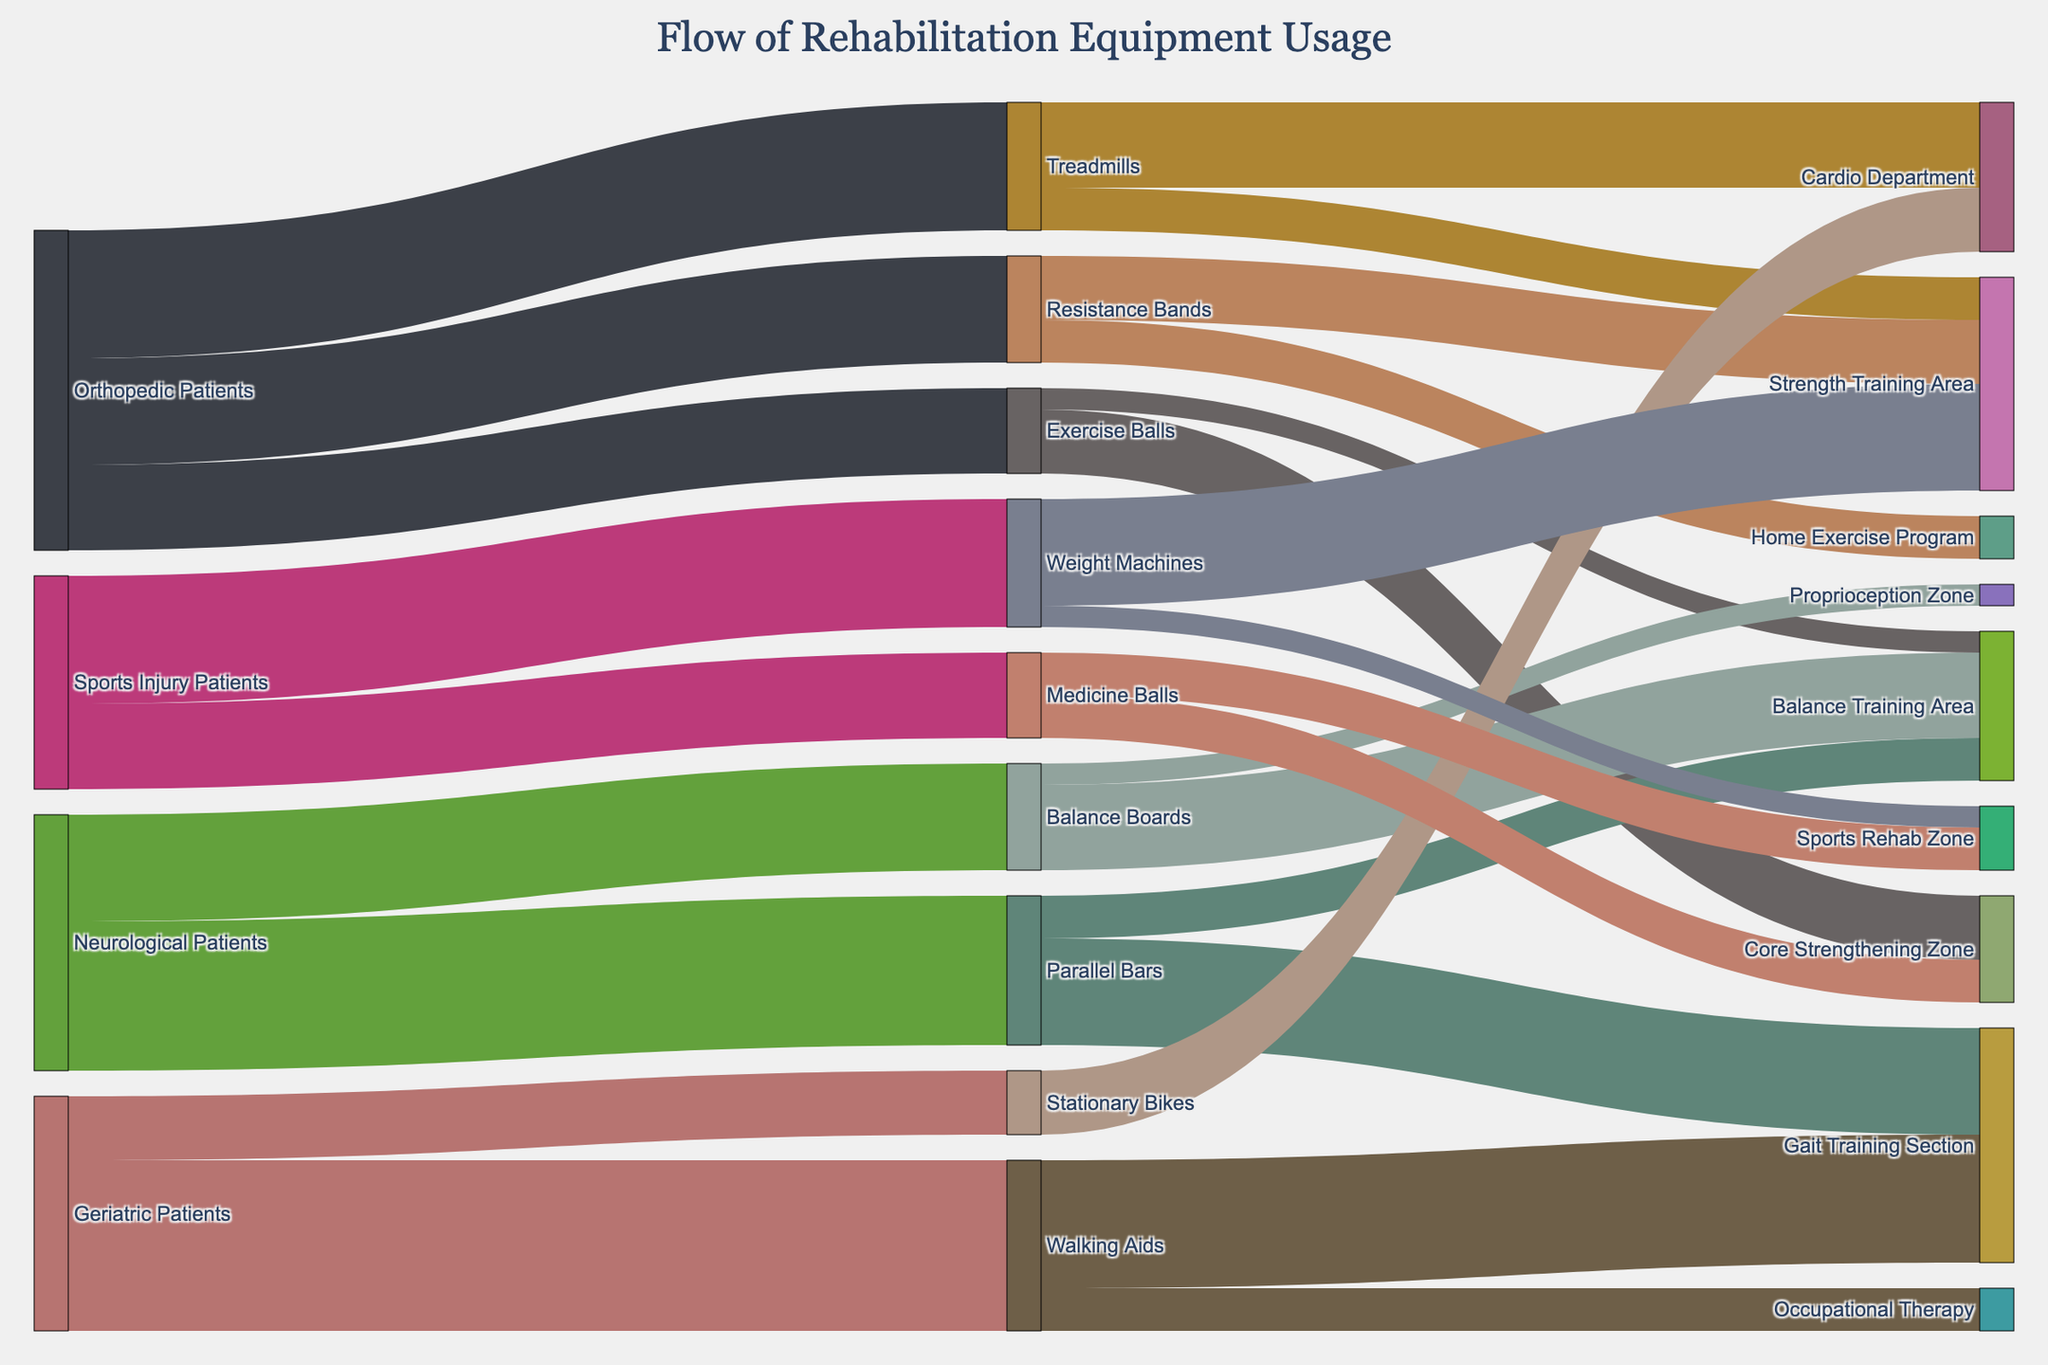What therapy department receives the most usage of Treadmills? Treadmills split usage between the Cardio Department and Strength Training Area. According to the figure, the Cardio Department receives 20 units, and the Strength Training Area receives 10 units. Therefore, the Cardio Department receives the most usage of Treadmills.
Answer: Cardio Department How many patient groups utilize the Resistance Bands? To determine this, identify all the distinct patient groups (source nodes) that flow into the Resistance Bands. The figure shows only Orthopedic Patients flowing into Resistance Bands. So, only one patient group uses them.
Answer: One Compare the total equipment usage between Geriatric Patients and Orthopedic Patients. Summing up the flows for each group: Geriatric Patients use Walking Aids (40) and Stationary Bikes (15) for a total of 55. Orthopedic Patients use Treadmills (30), Resistance Bands (25), and Exercise Balls (20) for a total of 75. Therefore, Orthopedic Patients use more equipment.
Answer: Orthopedic Patients Which type of exercise equipment is used the most across all patient groups? Examine the target nodes to determine which equipment has the highest total value. Walking Aids receive 40 units, Treadmills 30 units, Parallel Bars 35 units, and others have smaller usage. Hence, Walking Aids have the highest usage.
Answer: Walking Aids What is the combined usage value of equipment in the Balance Training Area? Sum the values of all flows terminating at the Balance Training Area: Exercise Balls (5), Parallel Bars (10), and Balance Boards (20), resulting in a total value of 35.
Answer: 35 What is the unique feature of Sankey diagrams related to visualizing flow? Sankey diagrams uniquely represent the flow of data from sources to targets using links of varying width to illustrate the quantity of flow. This allows the viewer to easily see which sources contribute most to particular targets.
Answer: Representing flow quantity via link width Which area has more equipment usage: the Core Strengthening Zone or the Strength Training Area? Aggregate the flow values to each area: Core Strengthening Zone has Exercise Balls (15) and Medicine Balls (10) totaling 25, whereas Strength Training Area has Resistance Bands (15), Treadmills (10), and Weight Machines (25) totaling 50. Therefore, the Strength Training Area has more equipment usage.
Answer: Strength Training Area Which patient group primarily uses the Parallel Bars? Reference the sources flowing into Parallel Bars. Only Neurological Patients flow into Parallel Bars.
Answer: Neurological Patients Which piece of equipment has an equal distribution between two therapy departments? Look for equipment flowing evenly into two separate departments. Medicine Balls split evenly with 10 units each going to the Core Strengthening Zone and Sports Rehab Zone, giving them an equal distribution.
Answer: Medicine Balls How does the usage of Stationary Bikes compare between Geriatric Patients and the Cardio Department? Geriatric Patients have 15 units of Stationary Bikes usage, which directly goes into the Cardio Department. Both values are equivalent in the flow representation.
Answer: Equal 